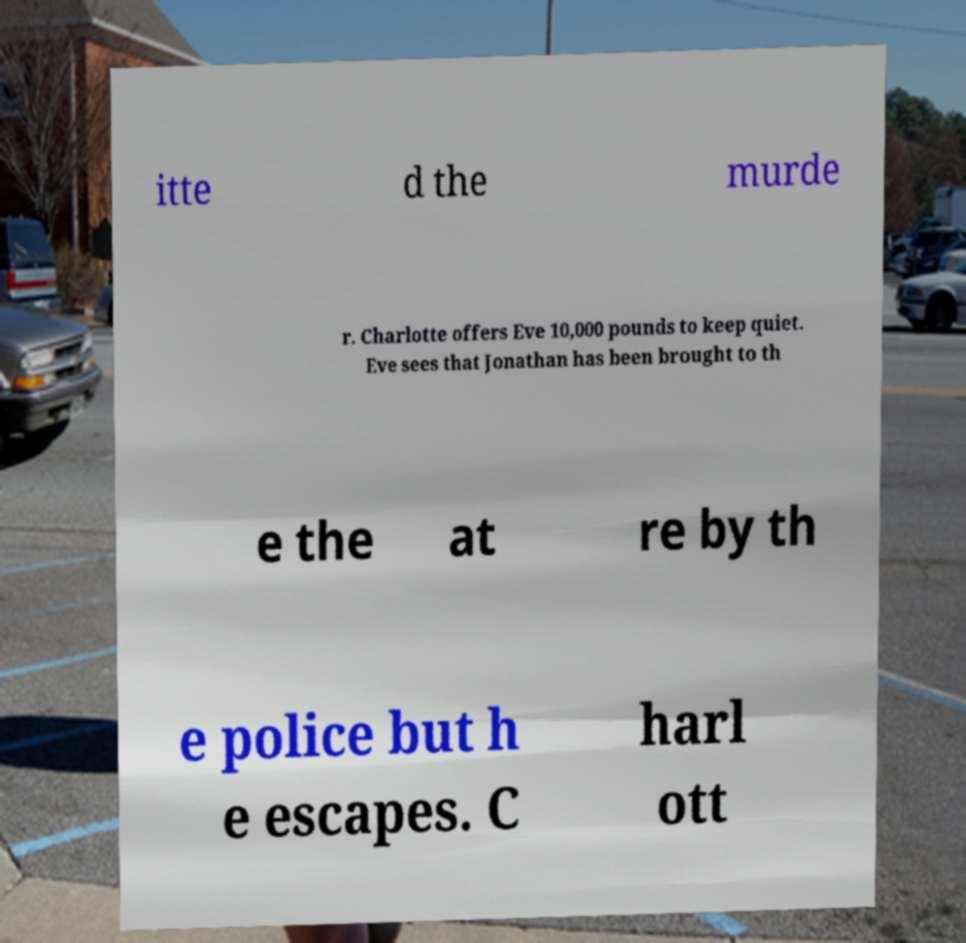Please read and relay the text visible in this image. What does it say? itte d the murde r. Charlotte offers Eve 10,000 pounds to keep quiet. Eve sees that Jonathan has been brought to th e the at re by th e police but h e escapes. C harl ott 